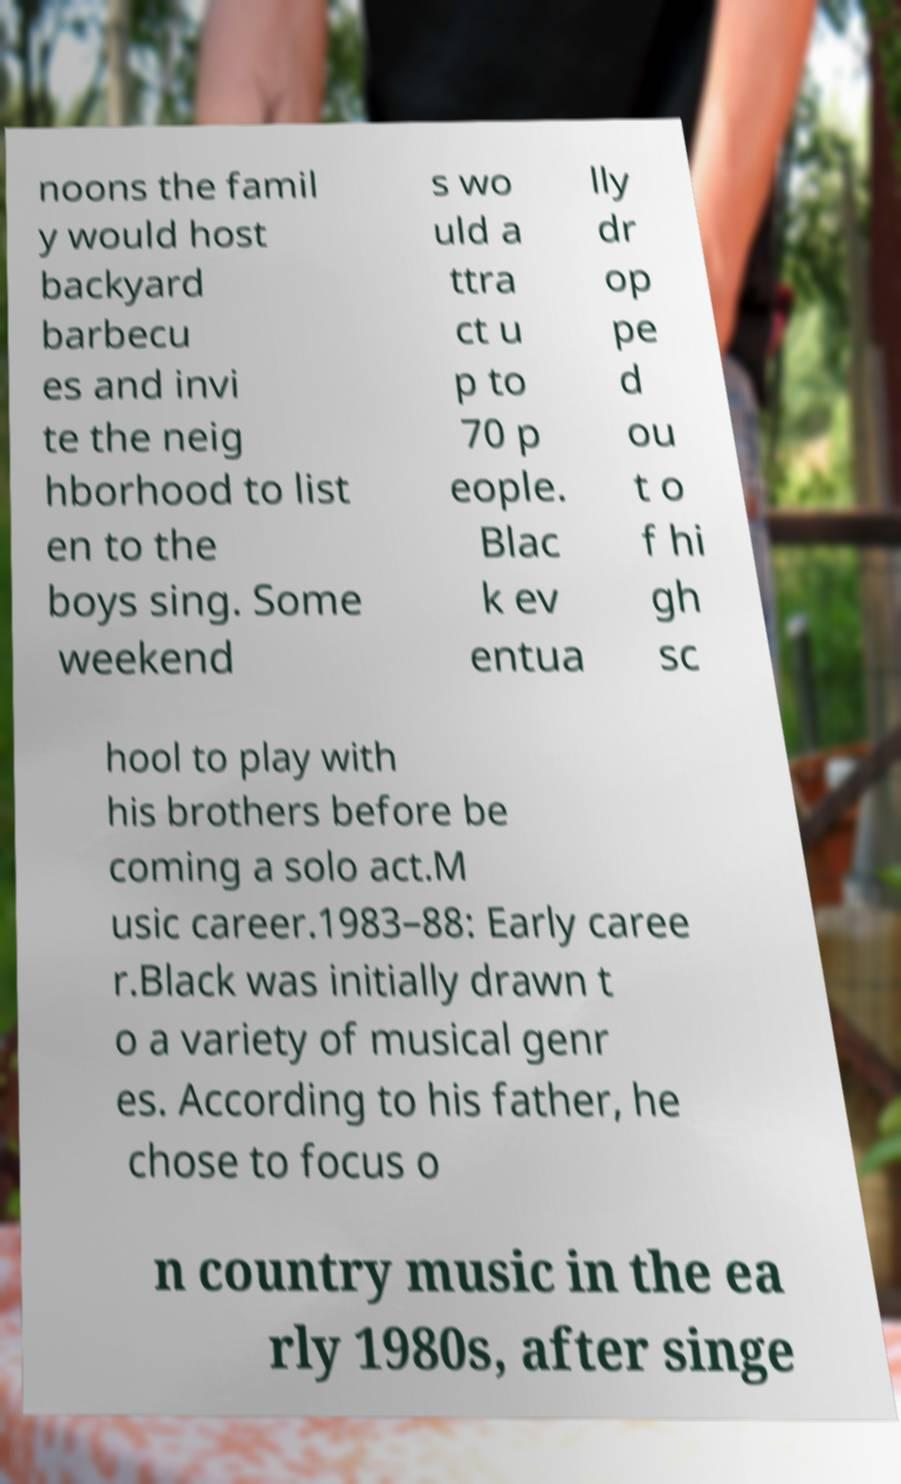Could you assist in decoding the text presented in this image and type it out clearly? noons the famil y would host backyard barbecu es and invi te the neig hborhood to list en to the boys sing. Some weekend s wo uld a ttra ct u p to 70 p eople. Blac k ev entua lly dr op pe d ou t o f hi gh sc hool to play with his brothers before be coming a solo act.M usic career.1983–88: Early caree r.Black was initially drawn t o a variety of musical genr es. According to his father, he chose to focus o n country music in the ea rly 1980s, after singe 